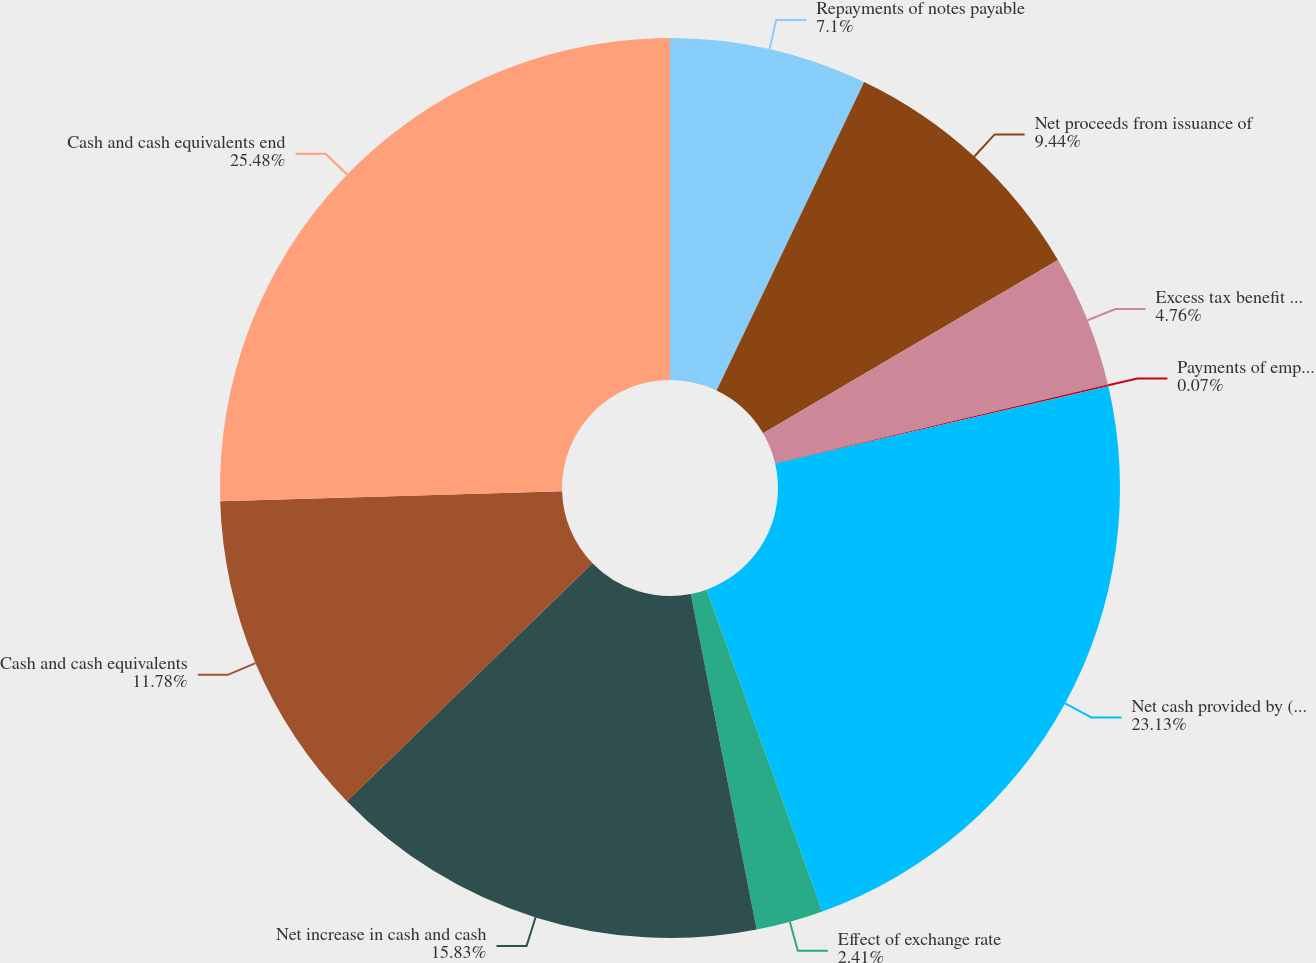Convert chart to OTSL. <chart><loc_0><loc_0><loc_500><loc_500><pie_chart><fcel>Repayments of notes payable<fcel>Net proceeds from issuance of<fcel>Excess tax benefit related to<fcel>Payments of employee<fcel>Net cash provided by (used in)<fcel>Effect of exchange rate<fcel>Net increase in cash and cash<fcel>Cash and cash equivalents<fcel>Cash and cash equivalents end<nl><fcel>7.1%<fcel>9.44%<fcel>4.76%<fcel>0.07%<fcel>23.13%<fcel>2.41%<fcel>15.83%<fcel>11.78%<fcel>25.47%<nl></chart> 